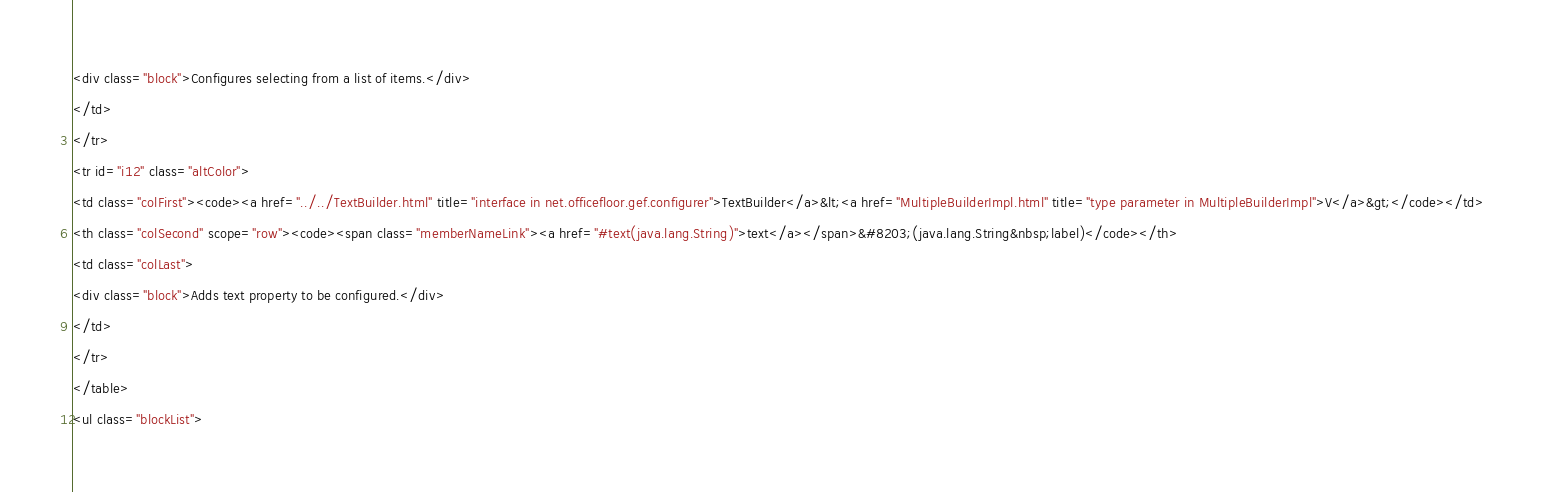Convert code to text. <code><loc_0><loc_0><loc_500><loc_500><_HTML_><div class="block">Configures selecting from a list of items.</div>
</td>
</tr>
<tr id="i12" class="altColor">
<td class="colFirst"><code><a href="../../TextBuilder.html" title="interface in net.officefloor.gef.configurer">TextBuilder</a>&lt;<a href="MultipleBuilderImpl.html" title="type parameter in MultipleBuilderImpl">V</a>&gt;</code></td>
<th class="colSecond" scope="row"><code><span class="memberNameLink"><a href="#text(java.lang.String)">text</a></span>&#8203;(java.lang.String&nbsp;label)</code></th>
<td class="colLast">
<div class="block">Adds text property to be configured.</div>
</td>
</tr>
</table>
<ul class="blockList"></code> 